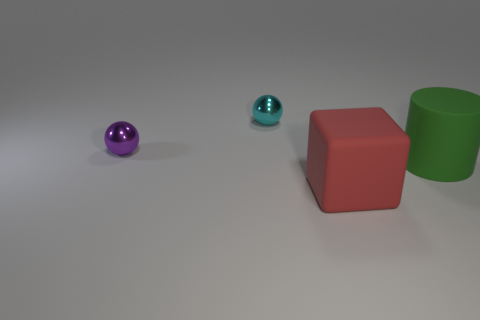Is there any other thing of the same color as the large rubber cube?
Provide a succinct answer. No. What is the size of the block that is the same material as the cylinder?
Provide a succinct answer. Large. What is the large object left of the rubber object behind the big thing in front of the green matte cylinder made of?
Ensure brevity in your answer.  Rubber. Are there fewer red blocks than big cyan objects?
Provide a short and direct response. No. Is the large block made of the same material as the purple ball?
Ensure brevity in your answer.  No. Does the small metallic sphere that is on the right side of the purple thing have the same color as the big block?
Ensure brevity in your answer.  No. What number of matte objects are in front of the matte thing behind the red rubber object?
Your response must be concise. 1. What color is the rubber thing that is the same size as the red cube?
Ensure brevity in your answer.  Green. What material is the small ball to the right of the tiny purple metal thing?
Ensure brevity in your answer.  Metal. What material is the object that is both in front of the small purple shiny sphere and on the left side of the green rubber cylinder?
Ensure brevity in your answer.  Rubber. 